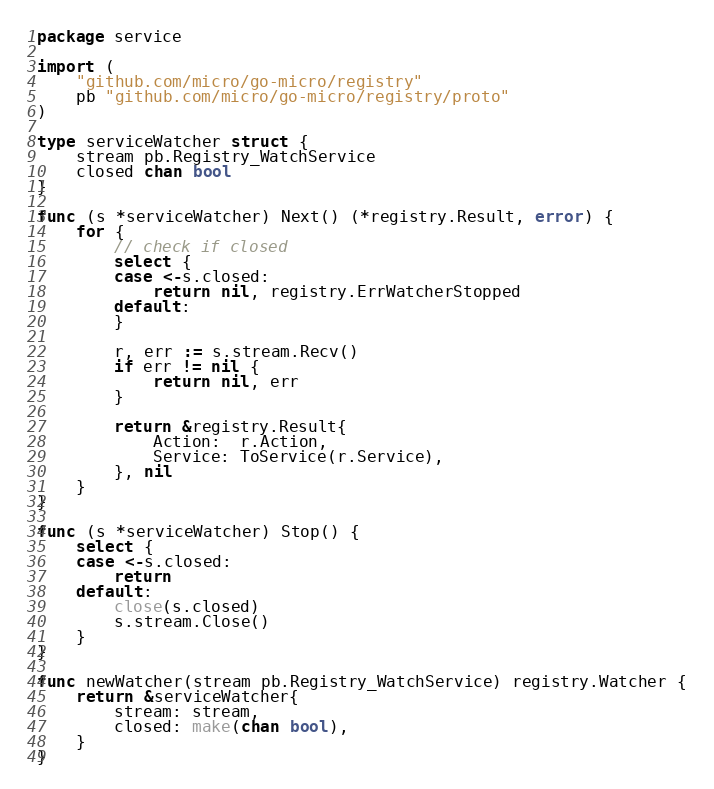Convert code to text. <code><loc_0><loc_0><loc_500><loc_500><_Go_>package service

import (
	"github.com/micro/go-micro/registry"
	pb "github.com/micro/go-micro/registry/proto"
)

type serviceWatcher struct {
	stream pb.Registry_WatchService
	closed chan bool
}

func (s *serviceWatcher) Next() (*registry.Result, error) {
	for {
		// check if closed
		select {
		case <-s.closed:
			return nil, registry.ErrWatcherStopped
		default:
		}

		r, err := s.stream.Recv()
		if err != nil {
			return nil, err
		}

		return &registry.Result{
			Action:  r.Action,
			Service: ToService(r.Service),
		}, nil
	}
}

func (s *serviceWatcher) Stop() {
	select {
	case <-s.closed:
		return
	default:
		close(s.closed)
		s.stream.Close()
	}
}

func newWatcher(stream pb.Registry_WatchService) registry.Watcher {
	return &serviceWatcher{
		stream: stream,
		closed: make(chan bool),
	}
}
</code> 